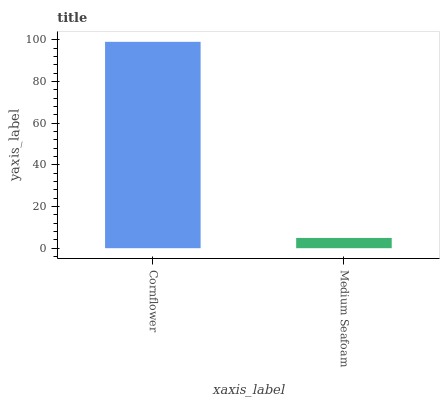Is Medium Seafoam the minimum?
Answer yes or no. Yes. Is Cornflower the maximum?
Answer yes or no. Yes. Is Medium Seafoam the maximum?
Answer yes or no. No. Is Cornflower greater than Medium Seafoam?
Answer yes or no. Yes. Is Medium Seafoam less than Cornflower?
Answer yes or no. Yes. Is Medium Seafoam greater than Cornflower?
Answer yes or no. No. Is Cornflower less than Medium Seafoam?
Answer yes or no. No. Is Cornflower the high median?
Answer yes or no. Yes. Is Medium Seafoam the low median?
Answer yes or no. Yes. Is Medium Seafoam the high median?
Answer yes or no. No. Is Cornflower the low median?
Answer yes or no. No. 